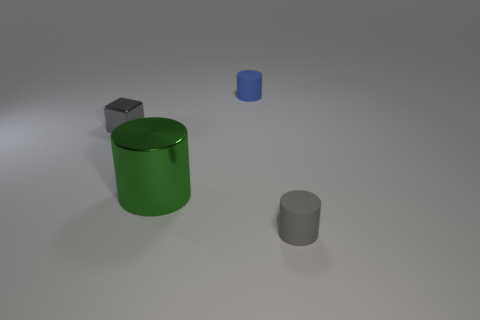Subtract all green metal cylinders. How many cylinders are left? 2 Add 4 gray objects. How many objects exist? 8 Subtract 1 cylinders. How many cylinders are left? 2 Subtract all blue cylinders. How many cylinders are left? 2 Subtract all cubes. How many objects are left? 3 Add 1 big purple shiny cylinders. How many big purple shiny cylinders exist? 1 Subtract 0 red blocks. How many objects are left? 4 Subtract all cyan cylinders. Subtract all cyan cubes. How many cylinders are left? 3 Subtract all green blocks. How many green cylinders are left? 1 Subtract all green cylinders. Subtract all large yellow matte spheres. How many objects are left? 3 